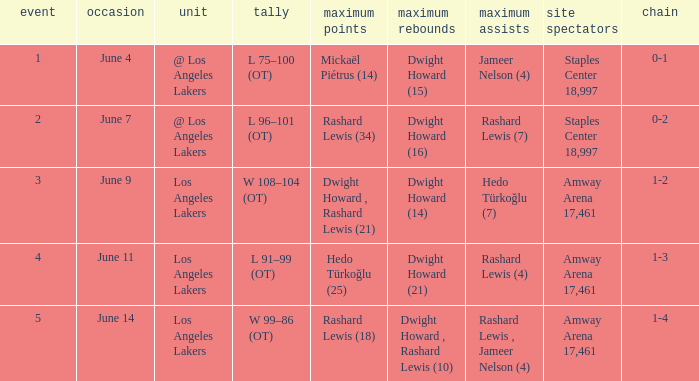What is Series, when Date is "June 7"? 0-2. 